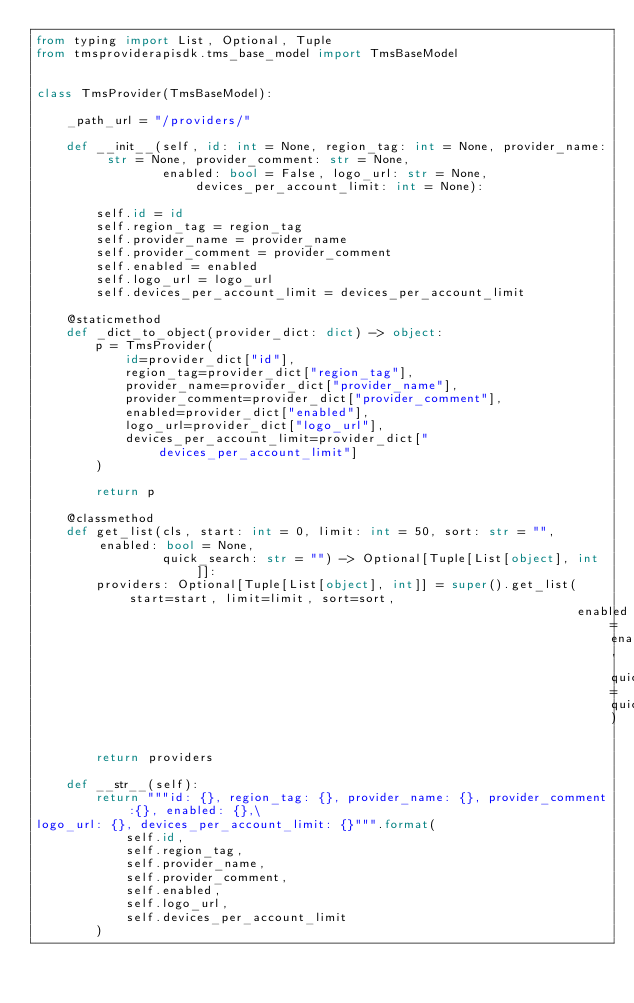<code> <loc_0><loc_0><loc_500><loc_500><_Python_>from typing import List, Optional, Tuple
from tmsproviderapisdk.tms_base_model import TmsBaseModel


class TmsProvider(TmsBaseModel):

    _path_url = "/providers/"

    def __init__(self, id: int = None, region_tag: int = None, provider_name: str = None, provider_comment: str = None,
                 enabled: bool = False, logo_url: str = None, devices_per_account_limit: int = None):

        self.id = id
        self.region_tag = region_tag
        self.provider_name = provider_name
        self.provider_comment = provider_comment
        self.enabled = enabled
        self.logo_url = logo_url
        self.devices_per_account_limit = devices_per_account_limit

    @staticmethod
    def _dict_to_object(provider_dict: dict) -> object:
        p = TmsProvider(
            id=provider_dict["id"],
            region_tag=provider_dict["region_tag"],
            provider_name=provider_dict["provider_name"],
            provider_comment=provider_dict["provider_comment"],
            enabled=provider_dict["enabled"],
            logo_url=provider_dict["logo_url"],
            devices_per_account_limit=provider_dict["devices_per_account_limit"]
        )

        return p

    @classmethod
    def get_list(cls, start: int = 0, limit: int = 50, sort: str = "", enabled: bool = None,
                 quick_search: str = "") -> Optional[Tuple[List[object], int]]:
        providers: Optional[Tuple[List[object], int]] = super().get_list(start=start, limit=limit, sort=sort,
                                                                         enabled=enabled, quick_search=quick_search)

        return providers

    def __str__(self):
        return """id: {}, region_tag: {}, provider_name: {}, provider_comment:{}, enabled: {},\
logo_url: {}, devices_per_account_limit: {}""".format(
            self.id,
            self.region_tag,
            self.provider_name,
            self.provider_comment,
            self.enabled,
            self.logo_url,
            self.devices_per_account_limit
        )
</code> 